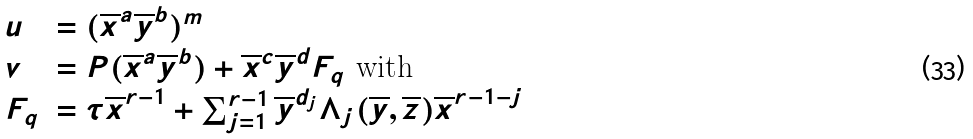Convert formula to latex. <formula><loc_0><loc_0><loc_500><loc_500>\begin{array} { l l } u & = ( \overline { x } ^ { a } \overline { y } ^ { b } ) ^ { m } \\ v & = P ( \overline { x } ^ { a } \overline { y } ^ { b } ) + \overline { x } ^ { c } \overline { y } ^ { d } F _ { q } \text { with } \\ F _ { q } & = \tau \overline { x } ^ { r - 1 } + \sum _ { j = 1 } ^ { r - 1 } \overline { y } ^ { d _ { j } } \Lambda _ { j } ( \overline { y } , \overline { z } ) \overline { x } ^ { r - 1 - j } \end{array}</formula> 